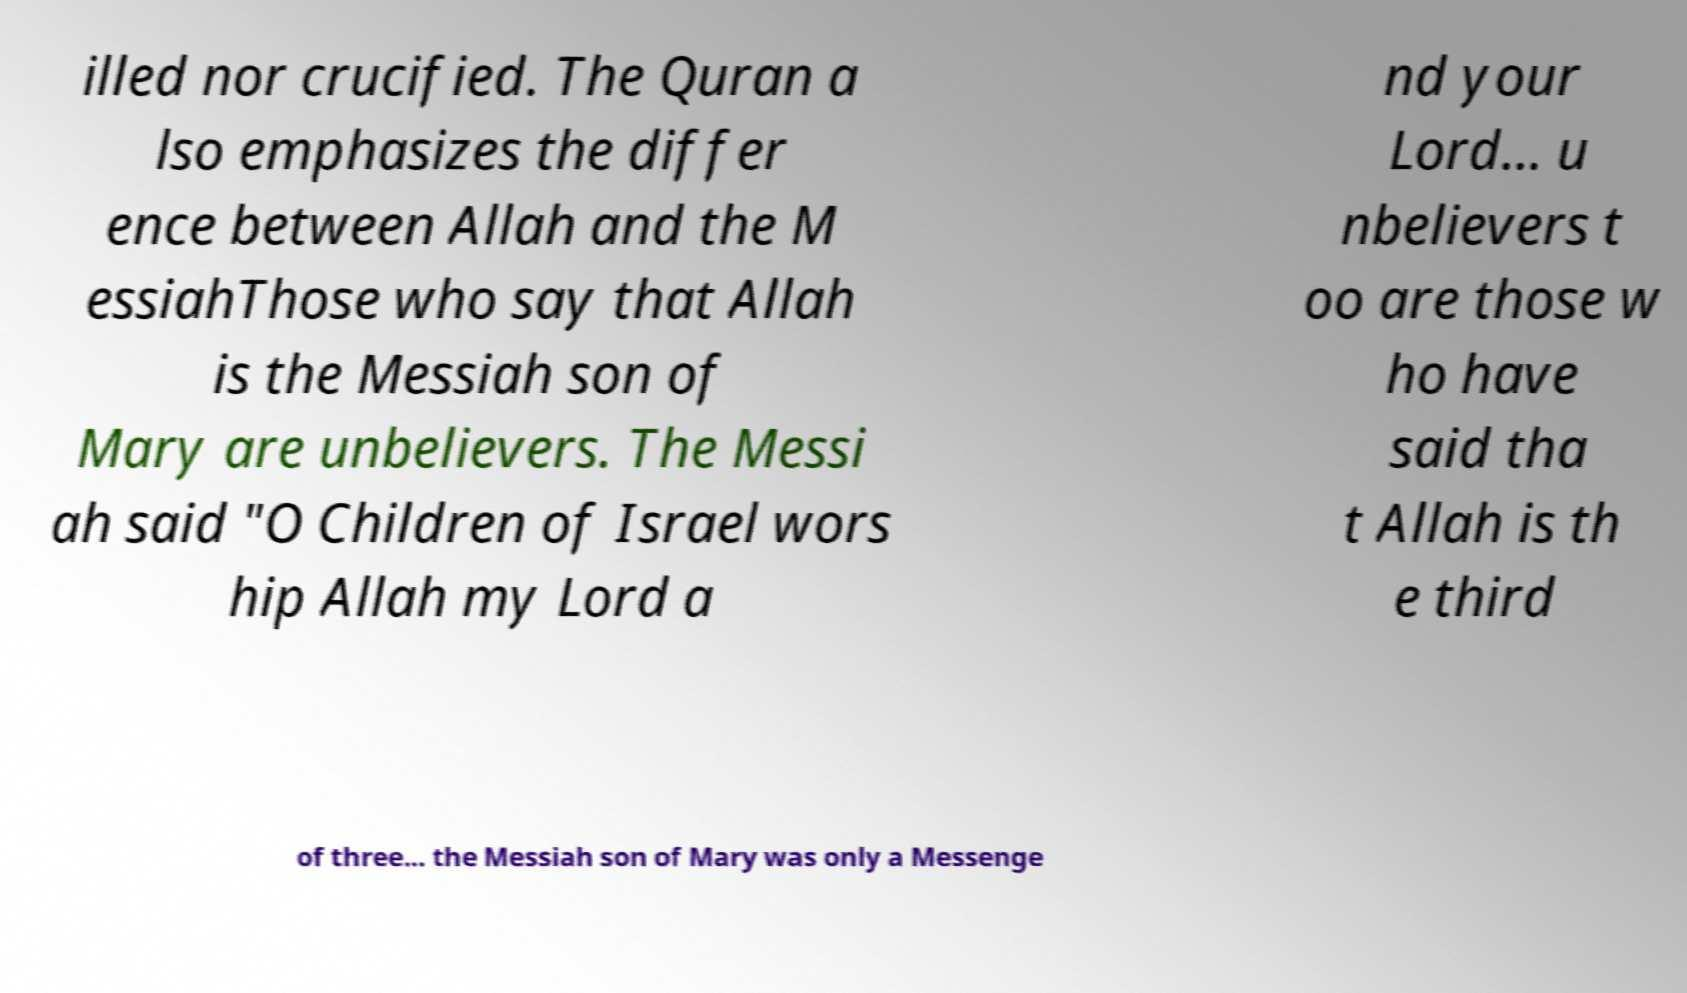Could you assist in decoding the text presented in this image and type it out clearly? illed nor crucified. The Quran a lso emphasizes the differ ence between Allah and the M essiahThose who say that Allah is the Messiah son of Mary are unbelievers. The Messi ah said "O Children of Israel wors hip Allah my Lord a nd your Lord... u nbelievers t oo are those w ho have said tha t Allah is th e third of three... the Messiah son of Mary was only a Messenge 